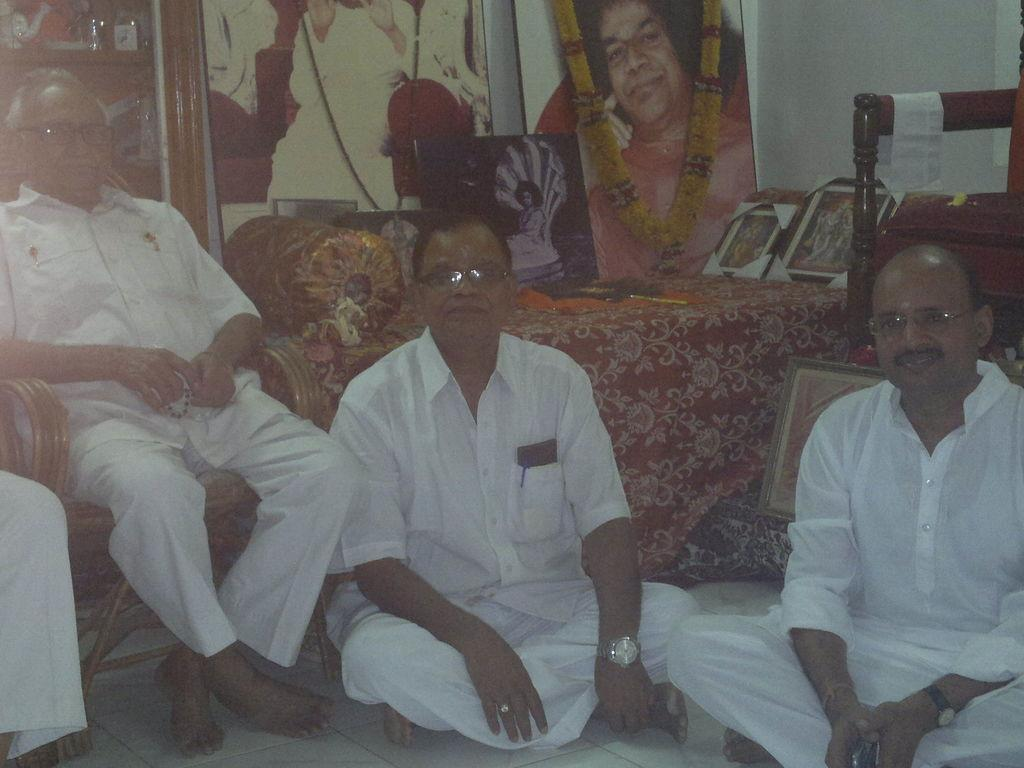Where was the image taken? The image was taken in a room. What can be seen in the foreground of the picture? There are men couches and frames in the foreground of the picture. What color is the wall in the room? The wall is painted white. What type of cracker is being served in the hospital room in the image? There is no hospital room or cracker present in the image; it is a room with men couches and frames. 